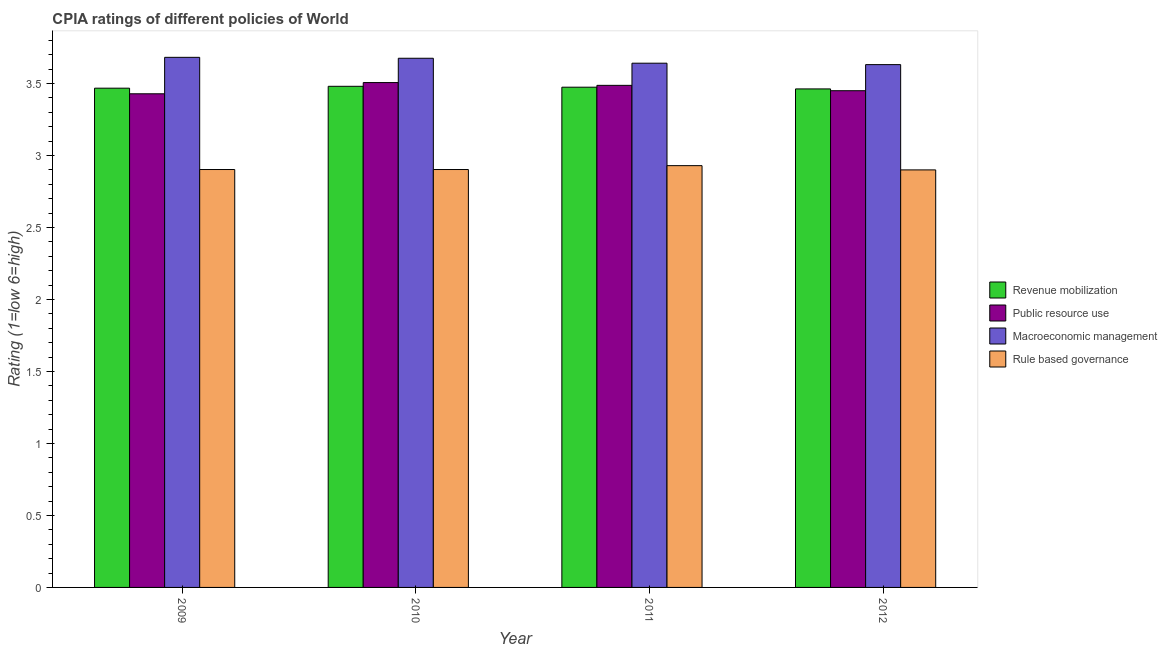How many different coloured bars are there?
Offer a very short reply. 4. How many groups of bars are there?
Give a very brief answer. 4. Are the number of bars on each tick of the X-axis equal?
Your response must be concise. Yes. How many bars are there on the 1st tick from the right?
Provide a succinct answer. 4. What is the cpia rating of revenue mobilization in 2010?
Your answer should be very brief. 3.48. Across all years, what is the maximum cpia rating of revenue mobilization?
Your answer should be very brief. 3.48. Across all years, what is the minimum cpia rating of macroeconomic management?
Your answer should be compact. 3.63. In which year was the cpia rating of rule based governance maximum?
Your answer should be very brief. 2011. In which year was the cpia rating of macroeconomic management minimum?
Make the answer very short. 2012. What is the total cpia rating of revenue mobilization in the graph?
Keep it short and to the point. 13.88. What is the difference between the cpia rating of macroeconomic management in 2010 and that in 2012?
Keep it short and to the point. 0.04. What is the difference between the cpia rating of public resource use in 2009 and the cpia rating of revenue mobilization in 2011?
Keep it short and to the point. -0.06. What is the average cpia rating of revenue mobilization per year?
Offer a very short reply. 3.47. What is the ratio of the cpia rating of macroeconomic management in 2010 to that in 2012?
Make the answer very short. 1.01. What is the difference between the highest and the second highest cpia rating of rule based governance?
Provide a succinct answer. 0.03. What is the difference between the highest and the lowest cpia rating of public resource use?
Offer a terse response. 0.08. In how many years, is the cpia rating of rule based governance greater than the average cpia rating of rule based governance taken over all years?
Your answer should be very brief. 1. Is the sum of the cpia rating of revenue mobilization in 2009 and 2012 greater than the maximum cpia rating of public resource use across all years?
Give a very brief answer. Yes. Is it the case that in every year, the sum of the cpia rating of macroeconomic management and cpia rating of public resource use is greater than the sum of cpia rating of rule based governance and cpia rating of revenue mobilization?
Your answer should be compact. Yes. What does the 4th bar from the left in 2009 represents?
Keep it short and to the point. Rule based governance. What does the 3rd bar from the right in 2011 represents?
Provide a succinct answer. Public resource use. Is it the case that in every year, the sum of the cpia rating of revenue mobilization and cpia rating of public resource use is greater than the cpia rating of macroeconomic management?
Your response must be concise. Yes. How many bars are there?
Make the answer very short. 16. How many years are there in the graph?
Your response must be concise. 4. What is the difference between two consecutive major ticks on the Y-axis?
Offer a very short reply. 0.5. Are the values on the major ticks of Y-axis written in scientific E-notation?
Your answer should be compact. No. How many legend labels are there?
Your answer should be compact. 4. How are the legend labels stacked?
Offer a very short reply. Vertical. What is the title of the graph?
Offer a terse response. CPIA ratings of different policies of World. What is the label or title of the X-axis?
Your response must be concise. Year. What is the label or title of the Y-axis?
Ensure brevity in your answer.  Rating (1=low 6=high). What is the Rating (1=low 6=high) in Revenue mobilization in 2009?
Offer a terse response. 3.47. What is the Rating (1=low 6=high) in Public resource use in 2009?
Ensure brevity in your answer.  3.43. What is the Rating (1=low 6=high) in Macroeconomic management in 2009?
Keep it short and to the point. 3.68. What is the Rating (1=low 6=high) of Rule based governance in 2009?
Keep it short and to the point. 2.9. What is the Rating (1=low 6=high) in Revenue mobilization in 2010?
Ensure brevity in your answer.  3.48. What is the Rating (1=low 6=high) in Public resource use in 2010?
Give a very brief answer. 3.51. What is the Rating (1=low 6=high) in Macroeconomic management in 2010?
Offer a very short reply. 3.68. What is the Rating (1=low 6=high) in Rule based governance in 2010?
Your answer should be very brief. 2.9. What is the Rating (1=low 6=high) in Revenue mobilization in 2011?
Offer a very short reply. 3.47. What is the Rating (1=low 6=high) of Public resource use in 2011?
Make the answer very short. 3.49. What is the Rating (1=low 6=high) of Macroeconomic management in 2011?
Your answer should be very brief. 3.64. What is the Rating (1=low 6=high) in Rule based governance in 2011?
Give a very brief answer. 2.93. What is the Rating (1=low 6=high) of Revenue mobilization in 2012?
Give a very brief answer. 3.46. What is the Rating (1=low 6=high) of Public resource use in 2012?
Your answer should be compact. 3.45. What is the Rating (1=low 6=high) of Macroeconomic management in 2012?
Provide a short and direct response. 3.63. Across all years, what is the maximum Rating (1=low 6=high) in Revenue mobilization?
Your response must be concise. 3.48. Across all years, what is the maximum Rating (1=low 6=high) in Public resource use?
Offer a very short reply. 3.51. Across all years, what is the maximum Rating (1=low 6=high) of Macroeconomic management?
Offer a terse response. 3.68. Across all years, what is the maximum Rating (1=low 6=high) in Rule based governance?
Provide a short and direct response. 2.93. Across all years, what is the minimum Rating (1=low 6=high) in Revenue mobilization?
Keep it short and to the point. 3.46. Across all years, what is the minimum Rating (1=low 6=high) of Public resource use?
Provide a short and direct response. 3.43. Across all years, what is the minimum Rating (1=low 6=high) of Macroeconomic management?
Provide a short and direct response. 3.63. What is the total Rating (1=low 6=high) in Revenue mobilization in the graph?
Provide a succinct answer. 13.88. What is the total Rating (1=low 6=high) of Public resource use in the graph?
Your answer should be very brief. 13.87. What is the total Rating (1=low 6=high) of Macroeconomic management in the graph?
Keep it short and to the point. 14.63. What is the total Rating (1=low 6=high) in Rule based governance in the graph?
Provide a succinct answer. 11.63. What is the difference between the Rating (1=low 6=high) of Revenue mobilization in 2009 and that in 2010?
Your answer should be very brief. -0.01. What is the difference between the Rating (1=low 6=high) of Public resource use in 2009 and that in 2010?
Make the answer very short. -0.08. What is the difference between the Rating (1=low 6=high) in Macroeconomic management in 2009 and that in 2010?
Provide a succinct answer. 0.01. What is the difference between the Rating (1=low 6=high) of Revenue mobilization in 2009 and that in 2011?
Your response must be concise. -0.01. What is the difference between the Rating (1=low 6=high) of Public resource use in 2009 and that in 2011?
Ensure brevity in your answer.  -0.06. What is the difference between the Rating (1=low 6=high) in Macroeconomic management in 2009 and that in 2011?
Ensure brevity in your answer.  0.04. What is the difference between the Rating (1=low 6=high) of Rule based governance in 2009 and that in 2011?
Make the answer very short. -0.03. What is the difference between the Rating (1=low 6=high) of Revenue mobilization in 2009 and that in 2012?
Offer a very short reply. 0.01. What is the difference between the Rating (1=low 6=high) in Public resource use in 2009 and that in 2012?
Provide a succinct answer. -0.02. What is the difference between the Rating (1=low 6=high) in Macroeconomic management in 2009 and that in 2012?
Provide a short and direct response. 0.05. What is the difference between the Rating (1=low 6=high) of Rule based governance in 2009 and that in 2012?
Give a very brief answer. 0. What is the difference between the Rating (1=low 6=high) in Revenue mobilization in 2010 and that in 2011?
Keep it short and to the point. 0.01. What is the difference between the Rating (1=low 6=high) of Public resource use in 2010 and that in 2011?
Ensure brevity in your answer.  0.02. What is the difference between the Rating (1=low 6=high) in Macroeconomic management in 2010 and that in 2011?
Offer a very short reply. 0.03. What is the difference between the Rating (1=low 6=high) of Rule based governance in 2010 and that in 2011?
Give a very brief answer. -0.03. What is the difference between the Rating (1=low 6=high) of Revenue mobilization in 2010 and that in 2012?
Make the answer very short. 0.02. What is the difference between the Rating (1=low 6=high) of Public resource use in 2010 and that in 2012?
Provide a succinct answer. 0.06. What is the difference between the Rating (1=low 6=high) in Macroeconomic management in 2010 and that in 2012?
Offer a terse response. 0.04. What is the difference between the Rating (1=low 6=high) in Rule based governance in 2010 and that in 2012?
Keep it short and to the point. 0. What is the difference between the Rating (1=low 6=high) of Revenue mobilization in 2011 and that in 2012?
Your response must be concise. 0.01. What is the difference between the Rating (1=low 6=high) of Public resource use in 2011 and that in 2012?
Ensure brevity in your answer.  0.04. What is the difference between the Rating (1=low 6=high) of Macroeconomic management in 2011 and that in 2012?
Your answer should be compact. 0.01. What is the difference between the Rating (1=low 6=high) of Rule based governance in 2011 and that in 2012?
Ensure brevity in your answer.  0.03. What is the difference between the Rating (1=low 6=high) in Revenue mobilization in 2009 and the Rating (1=low 6=high) in Public resource use in 2010?
Provide a short and direct response. -0.04. What is the difference between the Rating (1=low 6=high) of Revenue mobilization in 2009 and the Rating (1=low 6=high) of Macroeconomic management in 2010?
Provide a succinct answer. -0.21. What is the difference between the Rating (1=low 6=high) of Revenue mobilization in 2009 and the Rating (1=low 6=high) of Rule based governance in 2010?
Provide a short and direct response. 0.56. What is the difference between the Rating (1=low 6=high) of Public resource use in 2009 and the Rating (1=low 6=high) of Macroeconomic management in 2010?
Provide a short and direct response. -0.25. What is the difference between the Rating (1=low 6=high) in Public resource use in 2009 and the Rating (1=low 6=high) in Rule based governance in 2010?
Ensure brevity in your answer.  0.53. What is the difference between the Rating (1=low 6=high) of Macroeconomic management in 2009 and the Rating (1=low 6=high) of Rule based governance in 2010?
Your response must be concise. 0.78. What is the difference between the Rating (1=low 6=high) of Revenue mobilization in 2009 and the Rating (1=low 6=high) of Public resource use in 2011?
Make the answer very short. -0.02. What is the difference between the Rating (1=low 6=high) in Revenue mobilization in 2009 and the Rating (1=low 6=high) in Macroeconomic management in 2011?
Ensure brevity in your answer.  -0.17. What is the difference between the Rating (1=low 6=high) in Revenue mobilization in 2009 and the Rating (1=low 6=high) in Rule based governance in 2011?
Ensure brevity in your answer.  0.54. What is the difference between the Rating (1=low 6=high) in Public resource use in 2009 and the Rating (1=low 6=high) in Macroeconomic management in 2011?
Offer a terse response. -0.21. What is the difference between the Rating (1=low 6=high) in Public resource use in 2009 and the Rating (1=low 6=high) in Rule based governance in 2011?
Keep it short and to the point. 0.5. What is the difference between the Rating (1=low 6=high) of Macroeconomic management in 2009 and the Rating (1=low 6=high) of Rule based governance in 2011?
Make the answer very short. 0.75. What is the difference between the Rating (1=low 6=high) of Revenue mobilization in 2009 and the Rating (1=low 6=high) of Public resource use in 2012?
Keep it short and to the point. 0.02. What is the difference between the Rating (1=low 6=high) of Revenue mobilization in 2009 and the Rating (1=low 6=high) of Macroeconomic management in 2012?
Make the answer very short. -0.16. What is the difference between the Rating (1=low 6=high) in Revenue mobilization in 2009 and the Rating (1=low 6=high) in Rule based governance in 2012?
Keep it short and to the point. 0.57. What is the difference between the Rating (1=low 6=high) in Public resource use in 2009 and the Rating (1=low 6=high) in Macroeconomic management in 2012?
Make the answer very short. -0.2. What is the difference between the Rating (1=low 6=high) of Public resource use in 2009 and the Rating (1=low 6=high) of Rule based governance in 2012?
Ensure brevity in your answer.  0.53. What is the difference between the Rating (1=low 6=high) of Macroeconomic management in 2009 and the Rating (1=low 6=high) of Rule based governance in 2012?
Your answer should be compact. 0.78. What is the difference between the Rating (1=low 6=high) of Revenue mobilization in 2010 and the Rating (1=low 6=high) of Public resource use in 2011?
Ensure brevity in your answer.  -0.01. What is the difference between the Rating (1=low 6=high) of Revenue mobilization in 2010 and the Rating (1=low 6=high) of Macroeconomic management in 2011?
Give a very brief answer. -0.16. What is the difference between the Rating (1=low 6=high) of Revenue mobilization in 2010 and the Rating (1=low 6=high) of Rule based governance in 2011?
Offer a very short reply. 0.55. What is the difference between the Rating (1=low 6=high) of Public resource use in 2010 and the Rating (1=low 6=high) of Macroeconomic management in 2011?
Provide a succinct answer. -0.13. What is the difference between the Rating (1=low 6=high) in Public resource use in 2010 and the Rating (1=low 6=high) in Rule based governance in 2011?
Give a very brief answer. 0.58. What is the difference between the Rating (1=low 6=high) of Macroeconomic management in 2010 and the Rating (1=low 6=high) of Rule based governance in 2011?
Your answer should be compact. 0.75. What is the difference between the Rating (1=low 6=high) in Revenue mobilization in 2010 and the Rating (1=low 6=high) in Public resource use in 2012?
Ensure brevity in your answer.  0.03. What is the difference between the Rating (1=low 6=high) of Revenue mobilization in 2010 and the Rating (1=low 6=high) of Macroeconomic management in 2012?
Offer a very short reply. -0.15. What is the difference between the Rating (1=low 6=high) in Revenue mobilization in 2010 and the Rating (1=low 6=high) in Rule based governance in 2012?
Your answer should be very brief. 0.58. What is the difference between the Rating (1=low 6=high) of Public resource use in 2010 and the Rating (1=low 6=high) of Macroeconomic management in 2012?
Keep it short and to the point. -0.12. What is the difference between the Rating (1=low 6=high) of Public resource use in 2010 and the Rating (1=low 6=high) of Rule based governance in 2012?
Your answer should be very brief. 0.61. What is the difference between the Rating (1=low 6=high) of Macroeconomic management in 2010 and the Rating (1=low 6=high) of Rule based governance in 2012?
Offer a terse response. 0.78. What is the difference between the Rating (1=low 6=high) of Revenue mobilization in 2011 and the Rating (1=low 6=high) of Public resource use in 2012?
Offer a very short reply. 0.02. What is the difference between the Rating (1=low 6=high) in Revenue mobilization in 2011 and the Rating (1=low 6=high) in Macroeconomic management in 2012?
Make the answer very short. -0.16. What is the difference between the Rating (1=low 6=high) in Revenue mobilization in 2011 and the Rating (1=low 6=high) in Rule based governance in 2012?
Provide a succinct answer. 0.57. What is the difference between the Rating (1=low 6=high) in Public resource use in 2011 and the Rating (1=low 6=high) in Macroeconomic management in 2012?
Give a very brief answer. -0.14. What is the difference between the Rating (1=low 6=high) in Public resource use in 2011 and the Rating (1=low 6=high) in Rule based governance in 2012?
Give a very brief answer. 0.59. What is the difference between the Rating (1=low 6=high) of Macroeconomic management in 2011 and the Rating (1=low 6=high) of Rule based governance in 2012?
Offer a very short reply. 0.74. What is the average Rating (1=low 6=high) in Revenue mobilization per year?
Offer a very short reply. 3.47. What is the average Rating (1=low 6=high) of Public resource use per year?
Keep it short and to the point. 3.47. What is the average Rating (1=low 6=high) in Macroeconomic management per year?
Your answer should be very brief. 3.66. What is the average Rating (1=low 6=high) of Rule based governance per year?
Your answer should be very brief. 2.91. In the year 2009, what is the difference between the Rating (1=low 6=high) in Revenue mobilization and Rating (1=low 6=high) in Public resource use?
Offer a very short reply. 0.04. In the year 2009, what is the difference between the Rating (1=low 6=high) of Revenue mobilization and Rating (1=low 6=high) of Macroeconomic management?
Provide a succinct answer. -0.21. In the year 2009, what is the difference between the Rating (1=low 6=high) in Revenue mobilization and Rating (1=low 6=high) in Rule based governance?
Ensure brevity in your answer.  0.56. In the year 2009, what is the difference between the Rating (1=low 6=high) of Public resource use and Rating (1=low 6=high) of Macroeconomic management?
Your answer should be very brief. -0.25. In the year 2009, what is the difference between the Rating (1=low 6=high) of Public resource use and Rating (1=low 6=high) of Rule based governance?
Offer a terse response. 0.53. In the year 2009, what is the difference between the Rating (1=low 6=high) of Macroeconomic management and Rating (1=low 6=high) of Rule based governance?
Make the answer very short. 0.78. In the year 2010, what is the difference between the Rating (1=low 6=high) of Revenue mobilization and Rating (1=low 6=high) of Public resource use?
Keep it short and to the point. -0.03. In the year 2010, what is the difference between the Rating (1=low 6=high) of Revenue mobilization and Rating (1=low 6=high) of Macroeconomic management?
Your answer should be very brief. -0.19. In the year 2010, what is the difference between the Rating (1=low 6=high) of Revenue mobilization and Rating (1=low 6=high) of Rule based governance?
Keep it short and to the point. 0.58. In the year 2010, what is the difference between the Rating (1=low 6=high) in Public resource use and Rating (1=low 6=high) in Macroeconomic management?
Provide a short and direct response. -0.17. In the year 2010, what is the difference between the Rating (1=low 6=high) in Public resource use and Rating (1=low 6=high) in Rule based governance?
Offer a terse response. 0.6. In the year 2010, what is the difference between the Rating (1=low 6=high) of Macroeconomic management and Rating (1=low 6=high) of Rule based governance?
Offer a terse response. 0.77. In the year 2011, what is the difference between the Rating (1=low 6=high) in Revenue mobilization and Rating (1=low 6=high) in Public resource use?
Your answer should be compact. -0.01. In the year 2011, what is the difference between the Rating (1=low 6=high) of Revenue mobilization and Rating (1=low 6=high) of Rule based governance?
Your answer should be compact. 0.54. In the year 2011, what is the difference between the Rating (1=low 6=high) in Public resource use and Rating (1=low 6=high) in Macroeconomic management?
Provide a short and direct response. -0.15. In the year 2011, what is the difference between the Rating (1=low 6=high) of Public resource use and Rating (1=low 6=high) of Rule based governance?
Provide a succinct answer. 0.56. In the year 2011, what is the difference between the Rating (1=low 6=high) of Macroeconomic management and Rating (1=low 6=high) of Rule based governance?
Offer a terse response. 0.71. In the year 2012, what is the difference between the Rating (1=low 6=high) in Revenue mobilization and Rating (1=low 6=high) in Public resource use?
Your response must be concise. 0.01. In the year 2012, what is the difference between the Rating (1=low 6=high) in Revenue mobilization and Rating (1=low 6=high) in Macroeconomic management?
Give a very brief answer. -0.17. In the year 2012, what is the difference between the Rating (1=low 6=high) of Revenue mobilization and Rating (1=low 6=high) of Rule based governance?
Provide a short and direct response. 0.56. In the year 2012, what is the difference between the Rating (1=low 6=high) of Public resource use and Rating (1=low 6=high) of Macroeconomic management?
Your answer should be compact. -0.18. In the year 2012, what is the difference between the Rating (1=low 6=high) of Public resource use and Rating (1=low 6=high) of Rule based governance?
Provide a short and direct response. 0.55. In the year 2012, what is the difference between the Rating (1=low 6=high) in Macroeconomic management and Rating (1=low 6=high) in Rule based governance?
Provide a succinct answer. 0.73. What is the ratio of the Rating (1=low 6=high) of Public resource use in 2009 to that in 2010?
Offer a very short reply. 0.98. What is the ratio of the Rating (1=low 6=high) of Public resource use in 2009 to that in 2011?
Provide a short and direct response. 0.98. What is the ratio of the Rating (1=low 6=high) in Macroeconomic management in 2009 to that in 2011?
Ensure brevity in your answer.  1.01. What is the ratio of the Rating (1=low 6=high) in Rule based governance in 2009 to that in 2011?
Provide a succinct answer. 0.99. What is the ratio of the Rating (1=low 6=high) of Macroeconomic management in 2009 to that in 2012?
Your answer should be very brief. 1.01. What is the ratio of the Rating (1=low 6=high) in Rule based governance in 2009 to that in 2012?
Your response must be concise. 1. What is the ratio of the Rating (1=low 6=high) in Macroeconomic management in 2010 to that in 2011?
Your response must be concise. 1.01. What is the ratio of the Rating (1=low 6=high) of Rule based governance in 2010 to that in 2011?
Make the answer very short. 0.99. What is the ratio of the Rating (1=low 6=high) in Revenue mobilization in 2010 to that in 2012?
Keep it short and to the point. 1.01. What is the ratio of the Rating (1=low 6=high) in Public resource use in 2010 to that in 2012?
Your answer should be compact. 1.02. What is the ratio of the Rating (1=low 6=high) in Macroeconomic management in 2010 to that in 2012?
Keep it short and to the point. 1.01. What is the ratio of the Rating (1=low 6=high) of Rule based governance in 2010 to that in 2012?
Ensure brevity in your answer.  1. What is the ratio of the Rating (1=low 6=high) in Revenue mobilization in 2011 to that in 2012?
Give a very brief answer. 1. What is the ratio of the Rating (1=low 6=high) of Public resource use in 2011 to that in 2012?
Offer a terse response. 1.01. What is the ratio of the Rating (1=low 6=high) of Macroeconomic management in 2011 to that in 2012?
Your answer should be compact. 1. What is the ratio of the Rating (1=low 6=high) of Rule based governance in 2011 to that in 2012?
Your response must be concise. 1.01. What is the difference between the highest and the second highest Rating (1=low 6=high) of Revenue mobilization?
Ensure brevity in your answer.  0.01. What is the difference between the highest and the second highest Rating (1=low 6=high) in Public resource use?
Provide a short and direct response. 0.02. What is the difference between the highest and the second highest Rating (1=low 6=high) in Macroeconomic management?
Provide a short and direct response. 0.01. What is the difference between the highest and the second highest Rating (1=low 6=high) of Rule based governance?
Offer a very short reply. 0.03. What is the difference between the highest and the lowest Rating (1=low 6=high) in Revenue mobilization?
Your answer should be very brief. 0.02. What is the difference between the highest and the lowest Rating (1=low 6=high) in Public resource use?
Provide a succinct answer. 0.08. What is the difference between the highest and the lowest Rating (1=low 6=high) in Macroeconomic management?
Keep it short and to the point. 0.05. What is the difference between the highest and the lowest Rating (1=low 6=high) in Rule based governance?
Offer a very short reply. 0.03. 